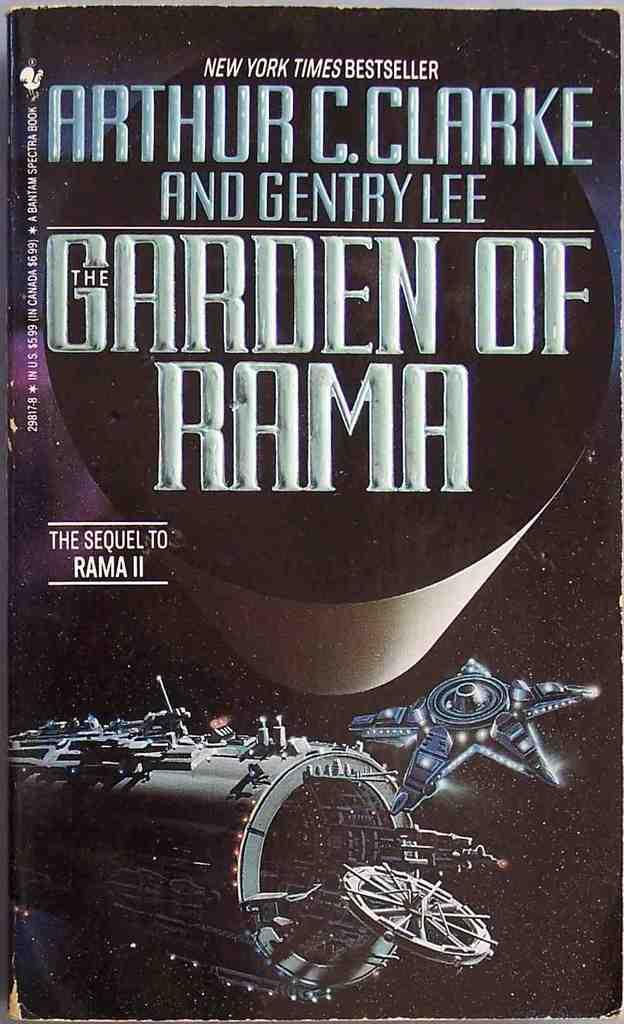<image>
Describe the image concisely. Arthur C. Clarke and Gentry Lee The Garden of Rama book. 